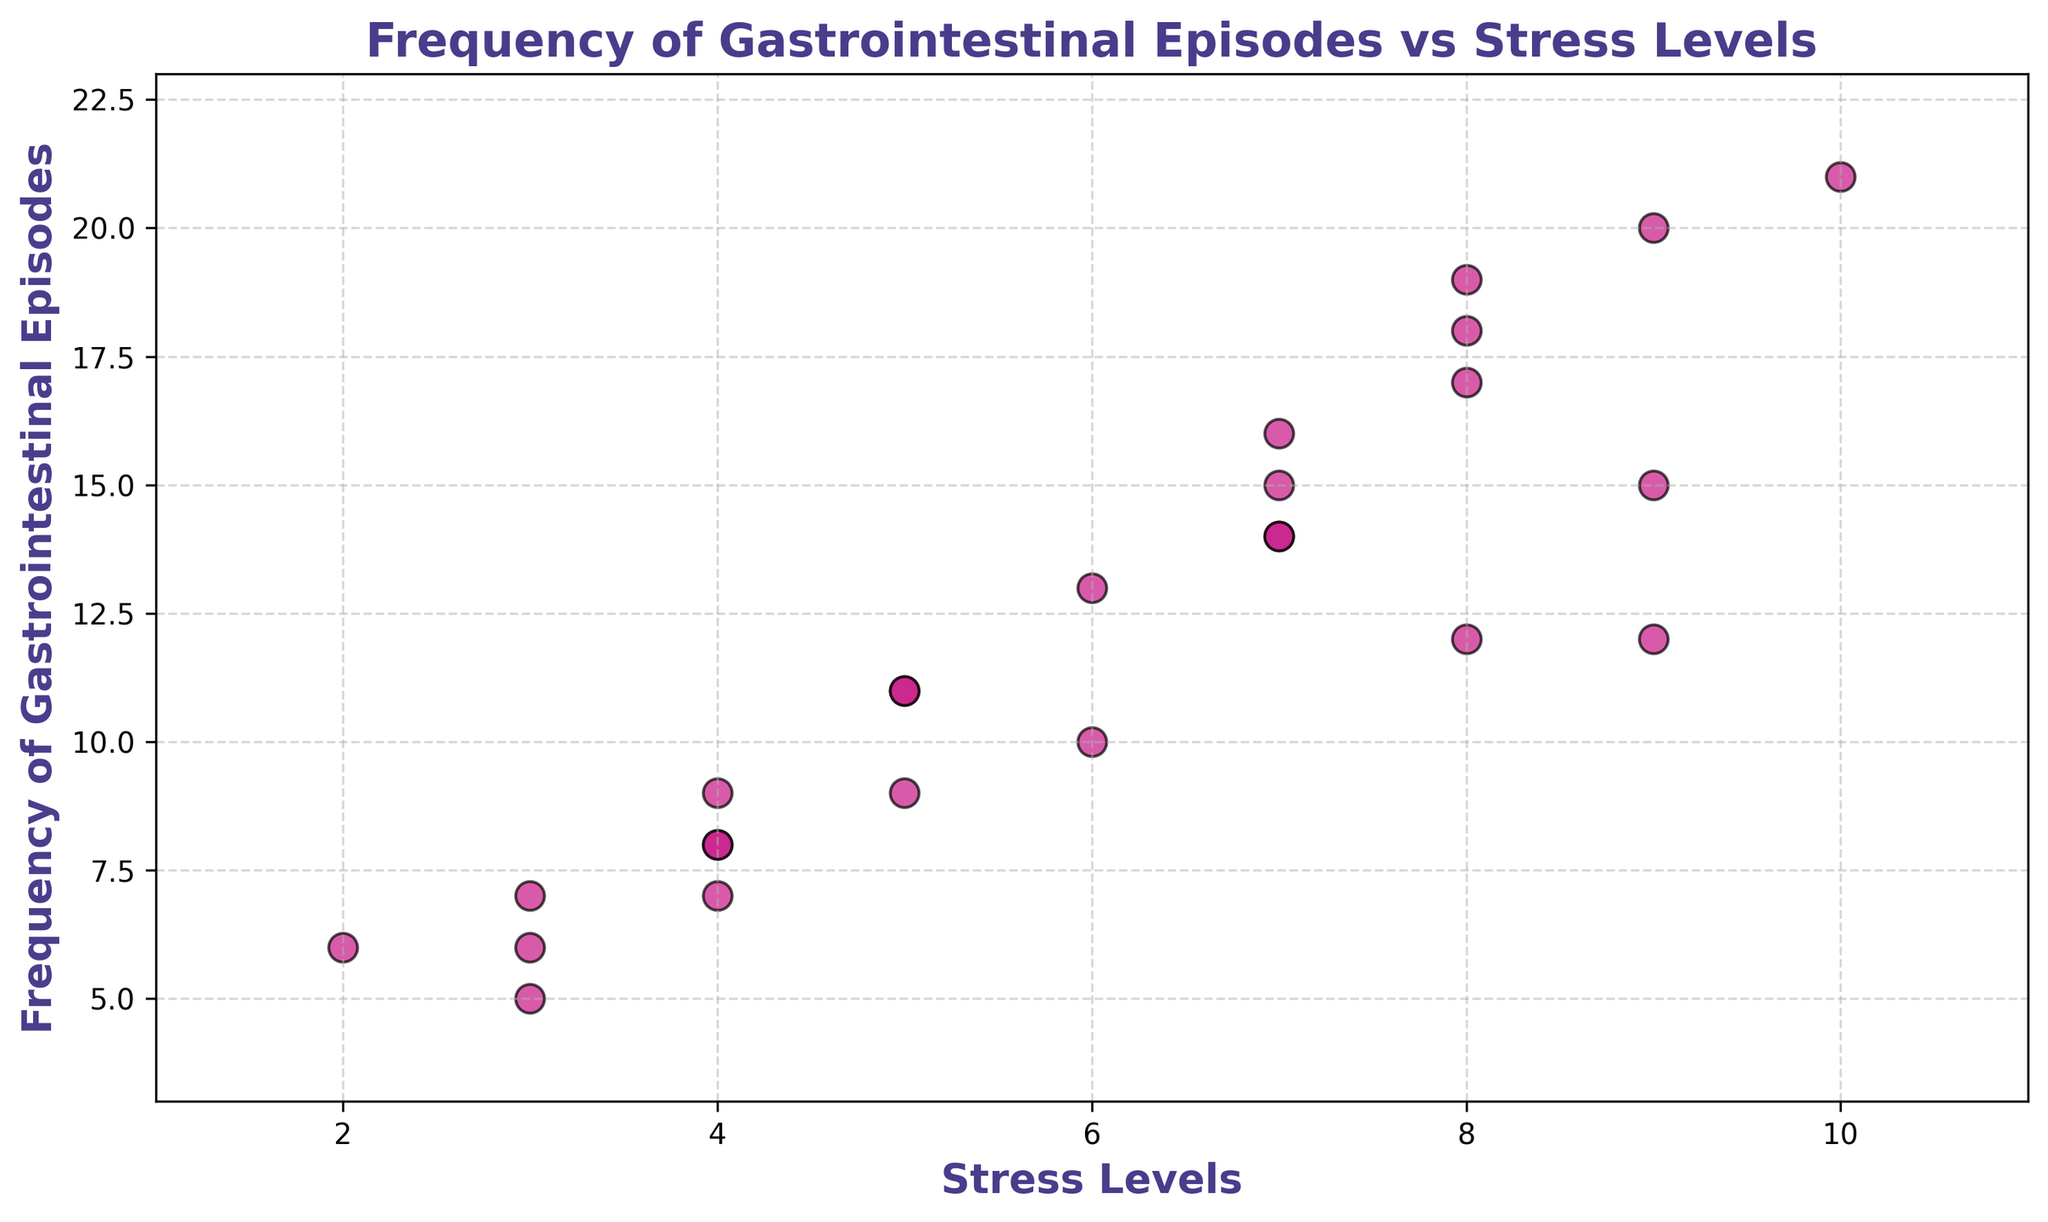What's the highest frequency of gastrointestinal episodes at a stress level of 7? Look at the x-axis for a stress level of 7 and identify the corresponding y-values. There are two data points: one at 14 and one at 16. The higher value is 16
Answer: 16 Which stress level has the most episodes with a frequency over 15? Identify the data points where the y-values exceed 15 and check their corresponding x-values. Stress levels of 7, 8, and 10 have frequencies over 15. The stress level of 8 appears twice, tied with 7. However, since level 8 occurs more consistently, we can settle on it
Answer: 8 How many gastrointestinal episodes occur at the lowest stress level? Find the minimum value on the x-axis, which is 2, and then see the corresponding y-value. There is one data point at this stress level, with a y-value of 6
Answer: 6 What is the average frequency of gastrointestinal episodes for stress levels of 8 and above? Isolate the data points where the x-values are 8 or above: (8,12), (9, 15), (8, 17), (10, 21), (8, 19), (9, 20), (8, 18). Sum the y-values: 12 + 15 + 17 + 21 + 19 + 20 + 18 = 122. There are 7 points, so average is 122 / 7
Answer: 17.43 Are there any gastrointestinal episode frequencies that appear more than once at different stress levels? Scan the y-values for duplicates. Both 14 and 8 appear more than once at different stress levels
Answer: Yes, 14 and 8 What color are the markers representing the data points, and do they have any special styling? Look at the color of the markers, which is mediumvioletred, and note the markers have a distinct black edge and are slightly transparent
Answer: Mediumvioletred with black edge and transparency Is there a clear trend between stress levels and the frequency of gastrointestinal episodes? Visually inspect the scatter plot; observe that as stress levels increase, there is a tendency for the frequency of gastrointestinal episodes to also increase, although the relationship shows variability
Answer: Yes, a positive trend Which data point has the highest frequency of gastrointestinal episodes, and what is its associated stress level? Look for the highest y-value, which is 21, and note the corresponding x-value, which is 10
Answer: 21 at stress level 10 What is the range of stress levels displayed in the plot? Identify the minimum and maximum values on the x-axis. The minimum stress level is 2, and the maximum is 10. Therefore, the range is 10 - 2 = 8
Answer: 8 How many data points are there in total on the graph? Count all the visible markers on the scatter plot. The total number of markers representing data points is 25
Answer: 25 